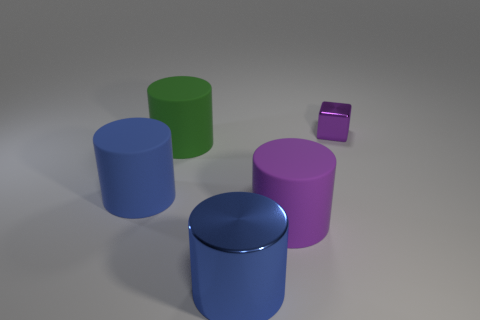Are there any patterns or textures on the objects? The objects have a smooth and matte finish, without visible patterns or textures, emphasizing the simplicity of their geometric shapes. What can you say about the composition of the objects in relation to each other? The objects are arranged in a manner where the negative space between them creates a balanced composition, with varying object heights and positions providing visual interest. 